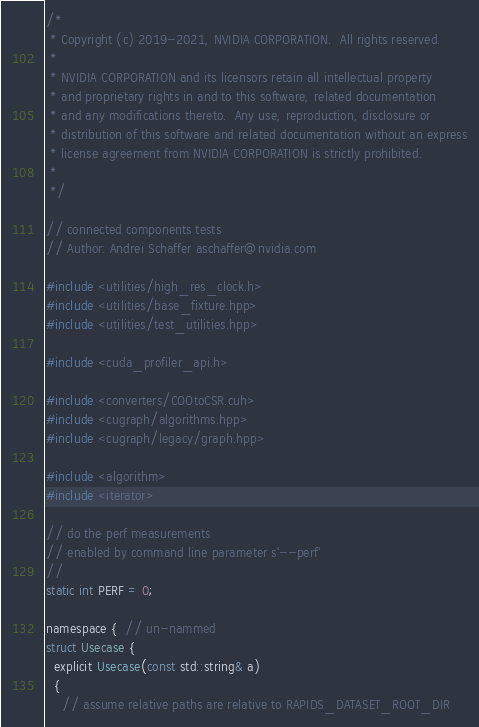<code> <loc_0><loc_0><loc_500><loc_500><_Cuda_>/*
 * Copyright (c) 2019-2021, NVIDIA CORPORATION.  All rights reserved.
 *
 * NVIDIA CORPORATION and its licensors retain all intellectual property
 * and proprietary rights in and to this software, related documentation
 * and any modifications thereto.  Any use, reproduction, disclosure or
 * distribution of this software and related documentation without an express
 * license agreement from NVIDIA CORPORATION is strictly prohibited.
 *
 */

// connected components tests
// Author: Andrei Schaffer aschaffer@nvidia.com

#include <utilities/high_res_clock.h>
#include <utilities/base_fixture.hpp>
#include <utilities/test_utilities.hpp>

#include <cuda_profiler_api.h>

#include <converters/COOtoCSR.cuh>
#include <cugraph/algorithms.hpp>
#include <cugraph/legacy/graph.hpp>

#include <algorithm>
#include <iterator>

// do the perf measurements
// enabled by command line parameter s'--perf'
//
static int PERF = 0;

namespace {  // un-nammed
struct Usecase {
  explicit Usecase(const std::string& a)
  {
    // assume relative paths are relative to RAPIDS_DATASET_ROOT_DIR</code> 